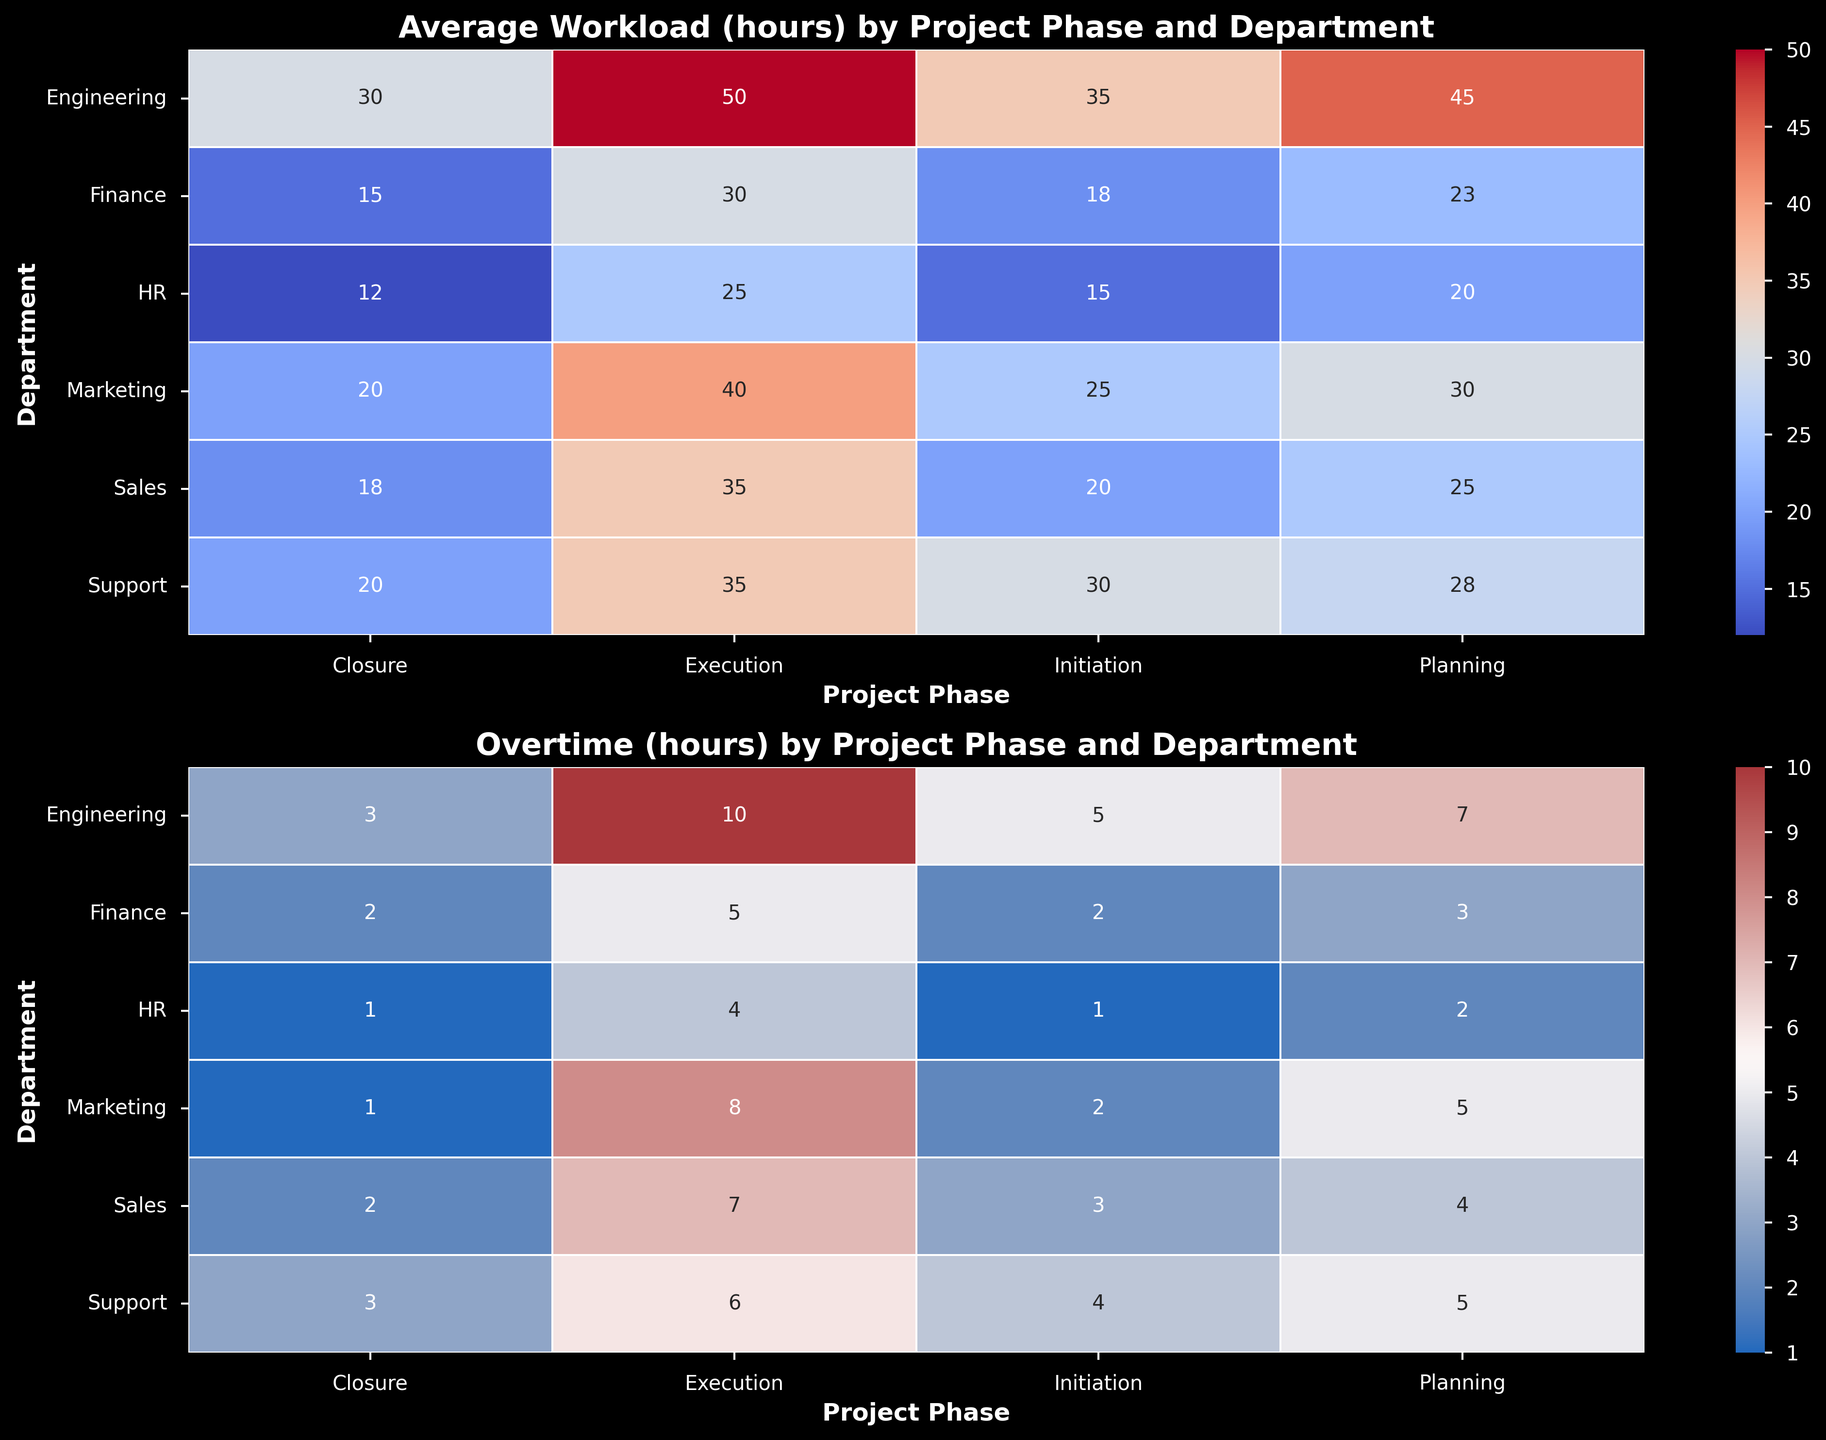Which department has the highest average workload during the Execution phase? The heatmap related to Average Workload color-codes the data. Look for the Execution phase column and identify the department with the highest value, which is Engineering.
Answer: Engineering What is the difference between the overtime hours in the Planning phase for Marketing and HR? Refer to the Overtime heatmap and find the values for Marketing and HR in the Planning phase. Marketing has 5 hours and HR has 2 hours. The difference is 5 - 2 = 3 hours.
Answer: 3 hours During which project phase does the Support department have the least average workload? Find the row for the Support department in the Average Workload heatmap and compare the values across all project phases. The Closure phase has the least workload with 20 hours.
Answer: Closure Compare the overtime hours between Engineering and Finance during the Initiation phase. Which has more and by how much? From the Overtime heatmap, Engineering in the Initiation phase has 5 hours, while Finance has 2 hours. Engineering has more overtime by 5 - 2 = 3 hours.
Answer: Engineering, 3 hours Which department has the least overtime during the Execution phase? Review the Overtime heatmap for the Execution phase column, and find the smallest value. The HR department has the least overtime with 4 hours.
Answer: HR Determine the sum of average workload hours for the Sales department across all project phases. Sum the values for Sales in the Average Workload heatmap: 20 (Initiation) + 25 (Planning) + 35 (Execution) + 18 (Closure) = 98 hours.
Answer: 98 hours What is the average overtime for the Engineering department across all project phases? Add up the overtime hours for Engineering from the Overtime heatmap and divide by the number of project phases: (5 + 7 + 10 + 3) / 4 = 25 / 4 = 6.25 hours.
Answer: 6.25 hours Which phase has the highest combined average workload hours across all departments? Add the average workload hours for all departments in each phase using the Average Workload heatmap. Execution has the highest combined value: 50 (Engineering) + 40 (Marketing) + 35 (Sales) + 25 (HR) + 30 (Finance) + 35 (Support) = 215 hours.
Answer: Execution, 215 hours Is there a direct relationship between average workload and overtime for departments during the Execution phase? Comparing the two heatmaps for the Execution phase, departments with higher average workload (Engineering, Marketing, Sales) generally also show higher overtime values. There is a positive correlation.
Answer: Yes What's the visual trend of average workload hours for HR across all project phases? In the Average Workload heatmap, trace HR row from Initiation to Closure. The workload decreases consistently: 15 -> 20 -> 25 -> 12 hours.
Answer: Decreasing trend 